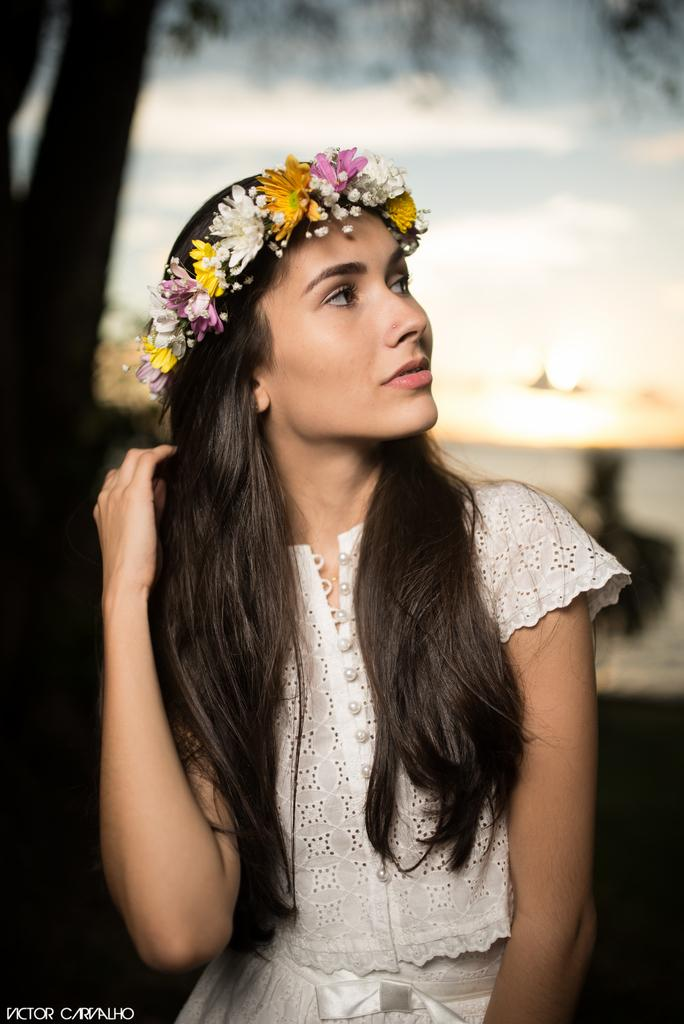Who is the main subject in the image? There is a woman in the image. What is the woman wearing? The woman is wearing a white dress and a flower crown on her head. Can you describe the background of the image? The background of the image is blurred. Where is the crook hiding in the image? There is no crook present in the image. What type of jail can be seen in the background of the image? There is no jail present in the image; the background is blurred. 